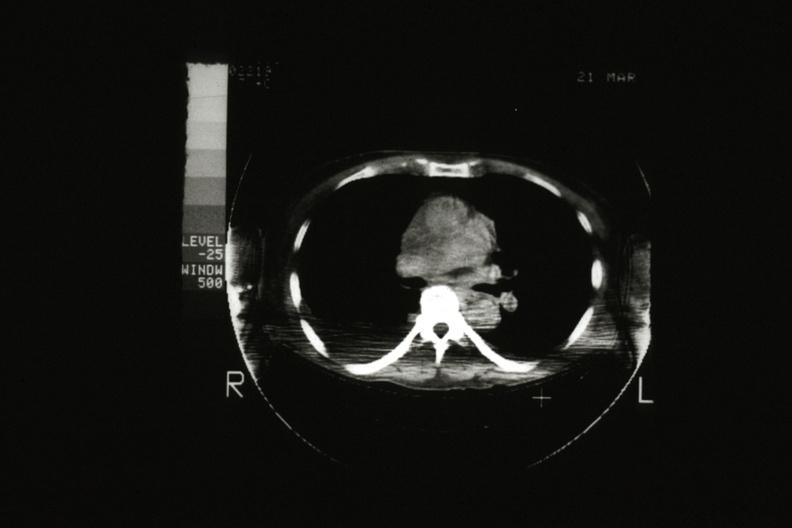s exact cause present?
Answer the question using a single word or phrase. No 